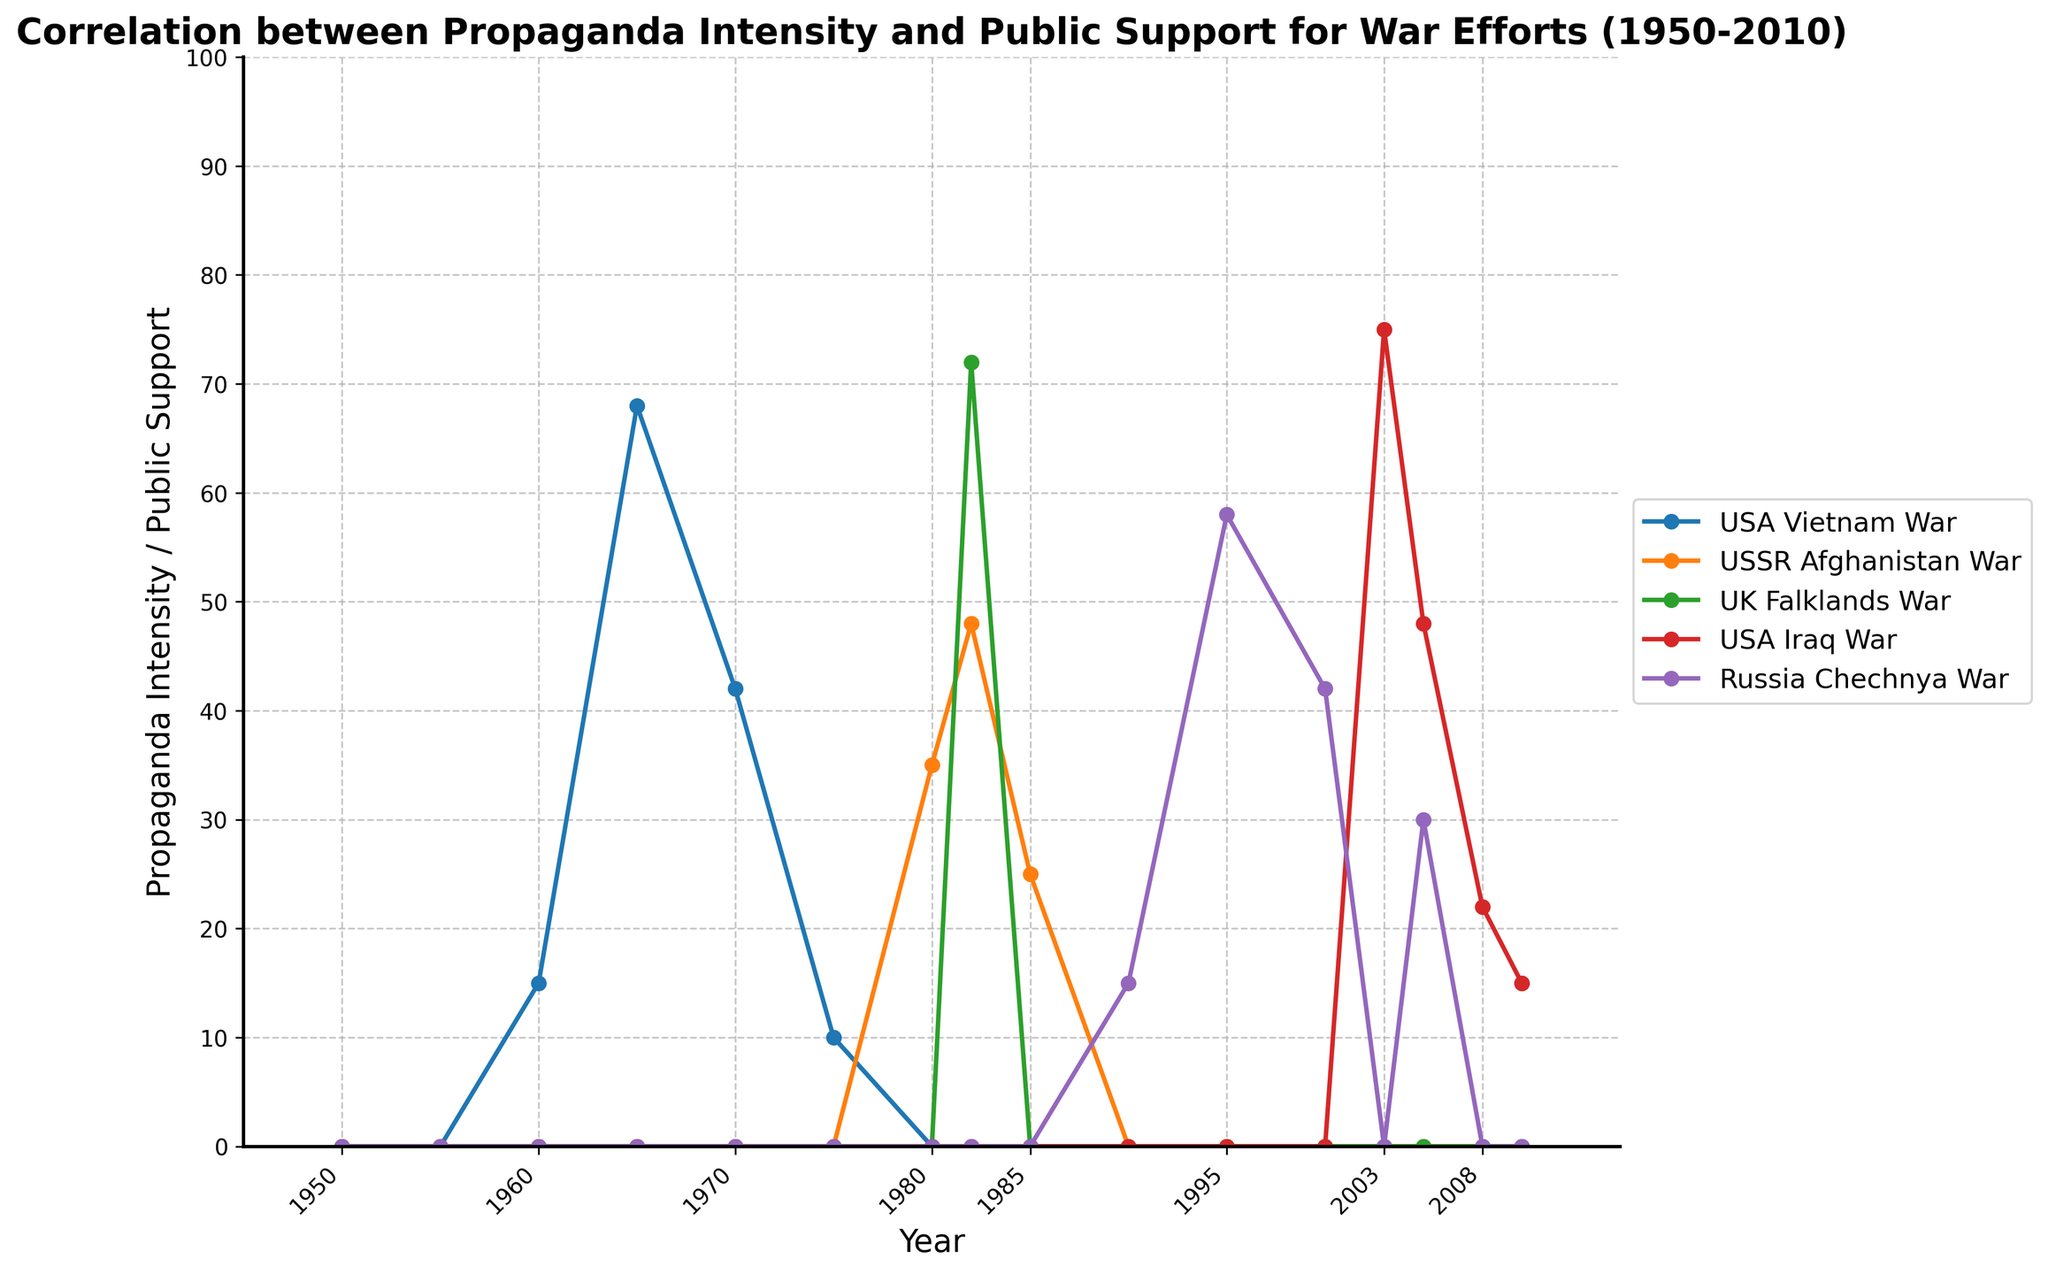Which war showed the highest peak in propaganda intensity during the 60-year span? To find the highest peak in propaganda intensity, look at the highest point on the graph for each conflict. The USA Vietnam War hits a peak at 68 in 1965, the USSR Afghanistan War reaches 48 in 1982, the UK Falklands War hits 72 in 1982, the USA Iraq War hits 75 in 2003, and the Russia Chechnya War peaks at 58 in 1995. The highest peak is for the USA Iraq War in 2003 with 75.
Answer: USA Iraq War How many conflicts had a propaganda intensity of zero in 1955? Check the values for each conflict in 1955. According to the plot, all conflicts (USA Vietnam War, USSR Afghanistan War, UK Falklands War, USA Iraq War, Russia Chechnya War) have a value of zero in 1955. Summarizing, all five conflicts had zero propaganda intensity.
Answer: Five Which conflict had the largest drop in propaganda intensity from its peak level? Identify the peak for each conflict, then find the largest drop to another value. The USA Vietnam War drops from 68 in 1965 to 10 in 1975, a drop of 58. The USSR Afghanistan War drops from 48 in 1982 to 25 in 1985, a drop of 23. The UK Falklands War drops from 72 in 1982 to 0 in 1983, a drop of 72. The USA Iraq War drops from 75 in 2003 to 15 in 2010, a drop of 60. The Russia Chechnya War drops from 58 in 1995 to 42 in 2000, a drop of 16. The largest drop is for the UK Falklands War, dropping 72 points.
Answer: UK Falklands War From 1990 to 2010, which conflict had a period with consistently rising propaganda intensity? Analyze the period from 1990 to 2010 for each conflict. The USA Iraq War shows a consistent rise in propaganda intensity from 0 in 1990 to a peak at 75 in 2003. Russia Chechnya War shows a decrease between 1995 and 2000, then another fluctuation. Hence, the USA Iraq War shows a consistent rise during this timeframe.
Answer: USA Iraq War What is the average propaganda intensity for the USA Vietnam War between 1960 and 1975 inclusive? Calculate the values for each year from 1960 to 1975: 15 (1960), 68 (1965), 42 (1970), and 10 (1975). The average is calculated as (15 + 68 + 42 + 10) / 4 = 135 / 4 = 33.75.
Answer: 33.75 